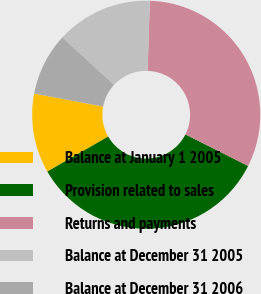Convert chart to OTSL. <chart><loc_0><loc_0><loc_500><loc_500><pie_chart><fcel>Balance at January 1 2005<fcel>Provision related to sales<fcel>Returns and payments<fcel>Balance at December 31 2005<fcel>Balance at December 31 2006<nl><fcel>11.27%<fcel>34.28%<fcel>31.91%<fcel>13.64%<fcel>8.9%<nl></chart> 